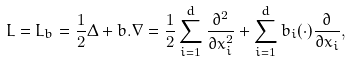<formula> <loc_0><loc_0><loc_500><loc_500>L = L _ { b } = \frac { 1 } { 2 } \Delta + b . \nabla = \frac { 1 } { 2 } \sum _ { i = 1 } ^ { d } \frac { \partial ^ { 2 } } { \partial x _ { i } ^ { 2 } } + \sum _ { i = 1 } ^ { d } b _ { i } ( \cdot ) \frac { \partial } { \partial x _ { i } } ,</formula> 